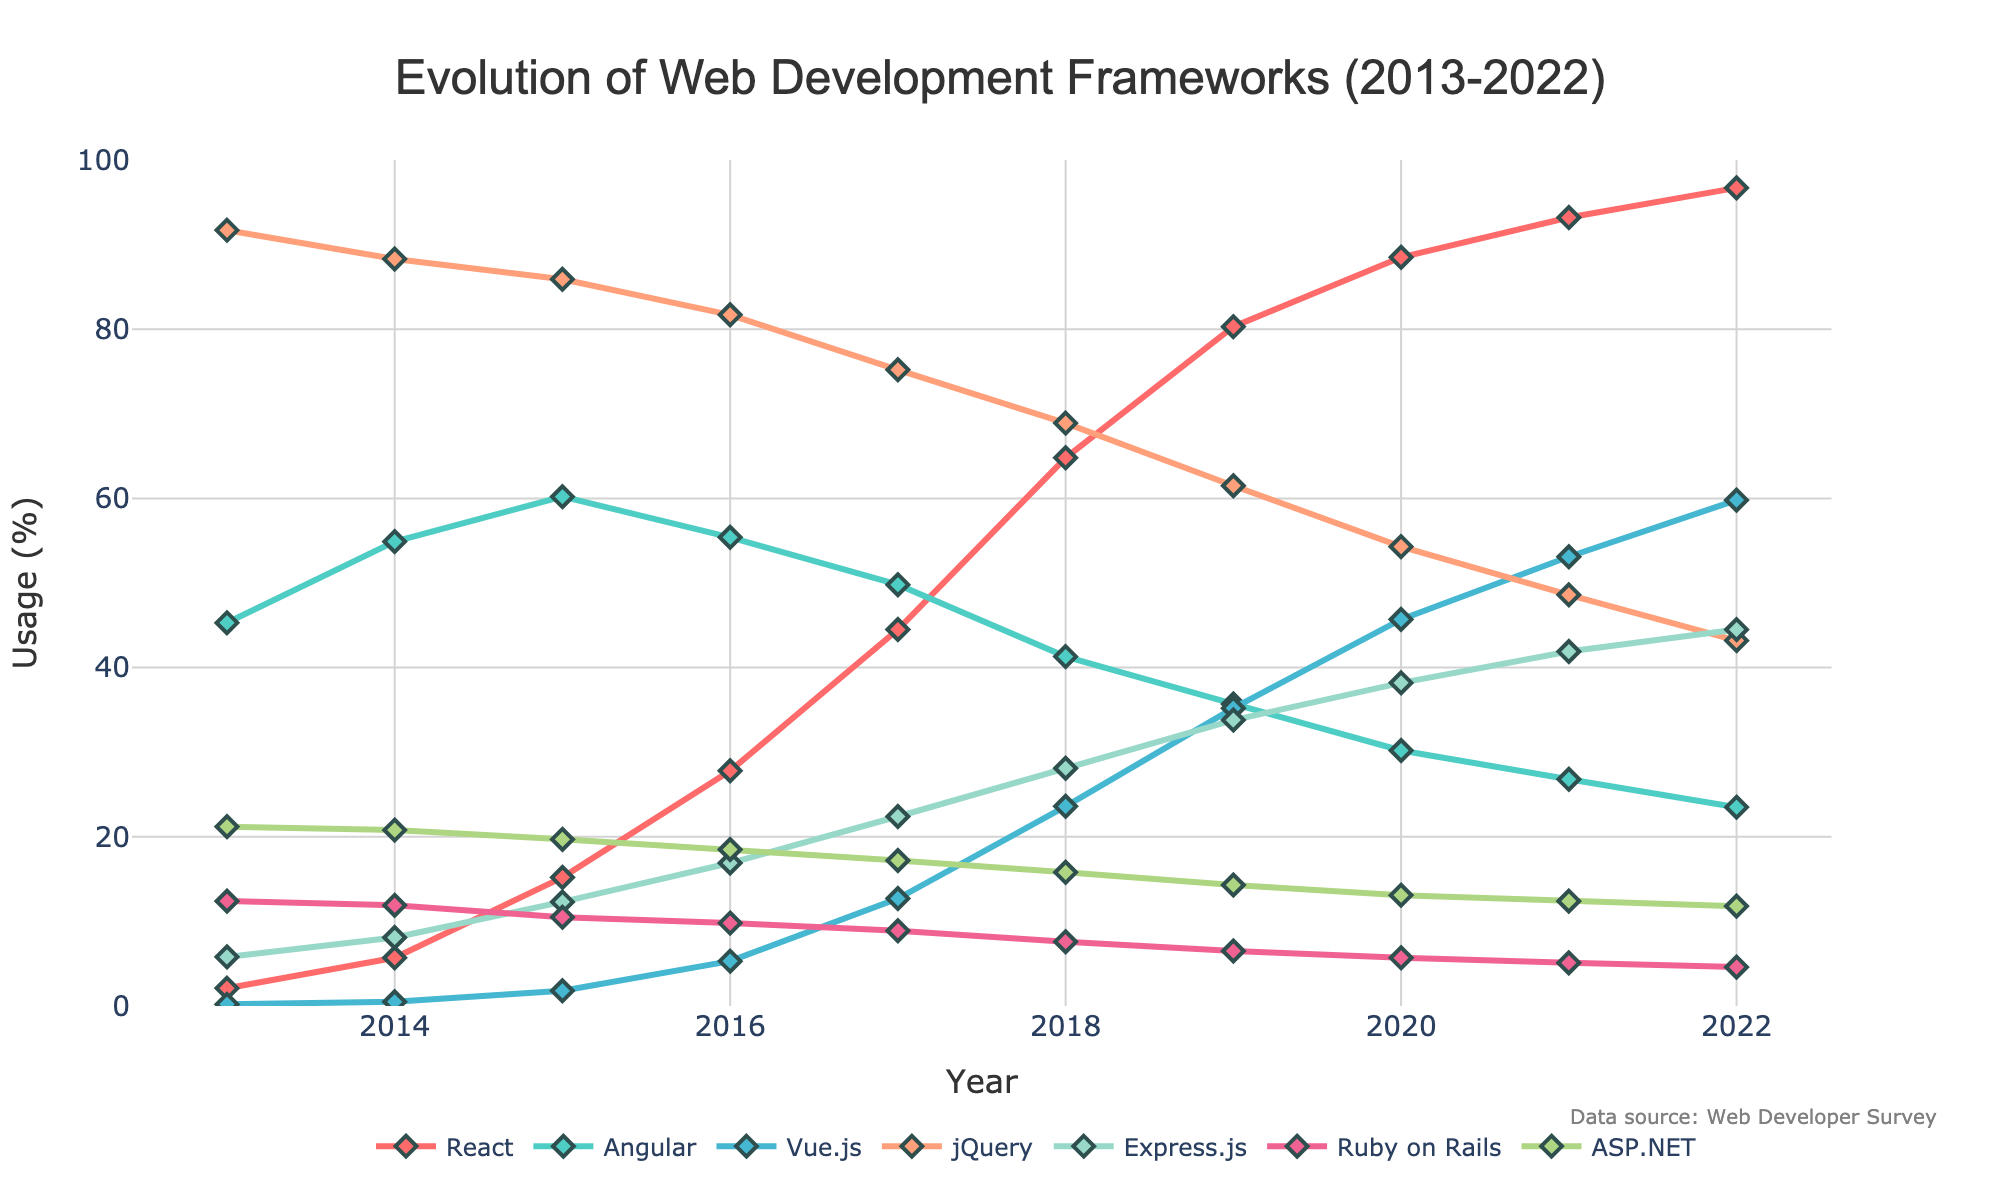What's the highest usage percentage React attained over the decade? React attained its highest usage percentage in 2022, reaching a value of 96.7%. This can be seen by following the orange line and identifying its peak value in the year 2022.
Answer: 96.7% In which year did Angular have its highest usage percentage? By observing the green line, we see that Angular's highest usage percentage was 60.2%, which occurred in 2015. This is evident as the green line peaks at 2015.
Answer: 2015 Which framework showed the most rapid increase in usage between 2013 and 2017? To determine the most rapid increase, we compare the changes in usage percentages over the four-year period for each framework. React had an increase from 2.1% to 44.5%, Vue.js from 0.2% to 12.7%, and others had smaller changes. React's increase of 42.4% is the largest.
Answer: React Compare the usage of jQuery and Express.js in 2022. Which one was more popular and by how much? In 2022, jQuery had a usage of 43.2%, while Express.js had 44.5%. Express.js was more popular by 44.5% - 43.2% = 1.3%.
Answer: Express.js, 1.3% What is the sum of the usage percentages of Ruby on Rails and ASP.NET in 2018? In 2018, Ruby on Rails had a usage of 7.6% and ASP.NET had 15.8%. Summing them gives 7.6% + 15.8% = 23.4%.
Answer: 23.4% How did the usage of Vue.js change from 2017 to 2019? Vue.js had a usage of 12.7% in 2017 and it increased to 35.2% in 2019. The change is 35.2% - 12.7% = 22.5%.
Answer: Increased by 22.5% Which framework had a consistent decline in usage over the decade? Observing all the lines, Angular is the framework with a consistent decline, starting from 45.3% in 2013 to 23.5% in 2022.
Answer: Angular Between which consecutive years did ASP.NET’s usage percentage decrease the most? By comparing the differences year-over-year for ASP.NET: 2013-14 (21.2%-20.8%=0.4%), 2014-15 (20.8%-19.7%=1.1%), and so forth, the largest decrease occurs between 2019 and 2020 (14.3% - 13.1% = 1.2%).
Answer: 2019-2020 